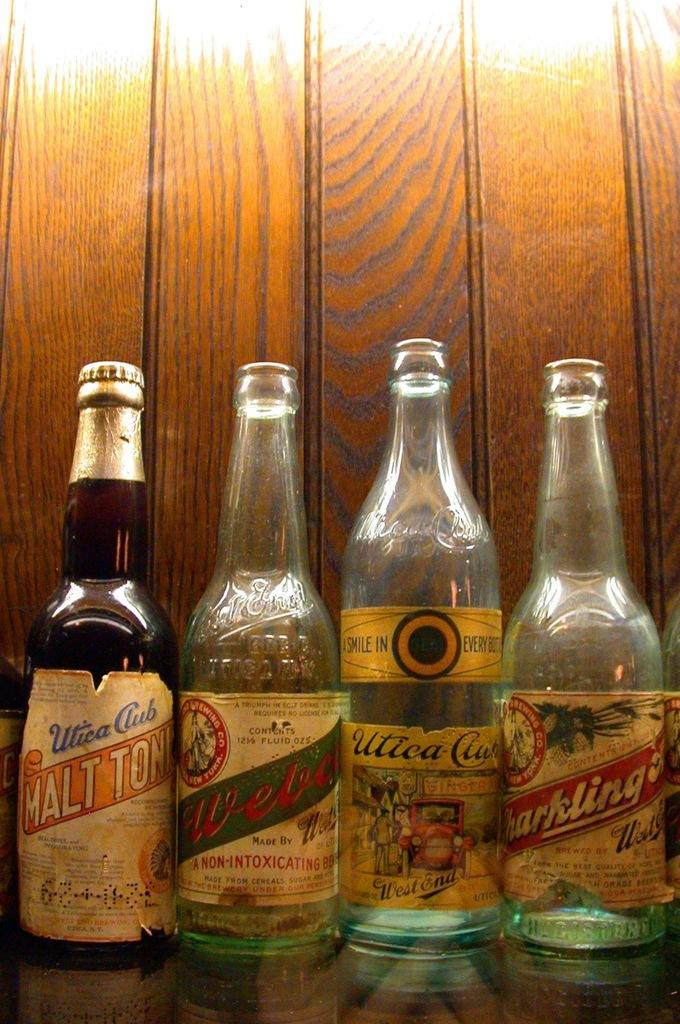How many bottles are visible in the image? There are four bottles in the image. What is on the bottles? The bottles have stickers on them. What can be seen in the background of the image? There is a wooden wall in the background of the image. What type of church is depicted on the stickers of the bottles? There is no church depicted on the stickers of the bottles; the stickers have unrelated designs or text. 